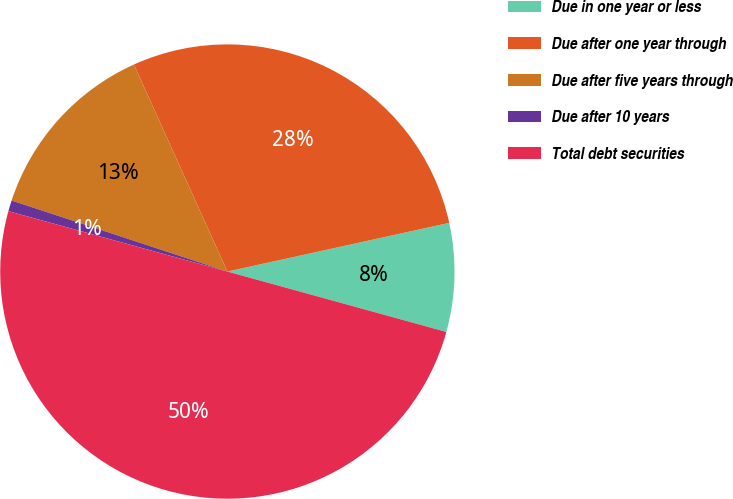<chart> <loc_0><loc_0><loc_500><loc_500><pie_chart><fcel>Due in one year or less<fcel>Due after one year through<fcel>Due after five years through<fcel>Due after 10 years<fcel>Total debt securities<nl><fcel>7.72%<fcel>28.31%<fcel>13.19%<fcel>0.78%<fcel>50.0%<nl></chart> 